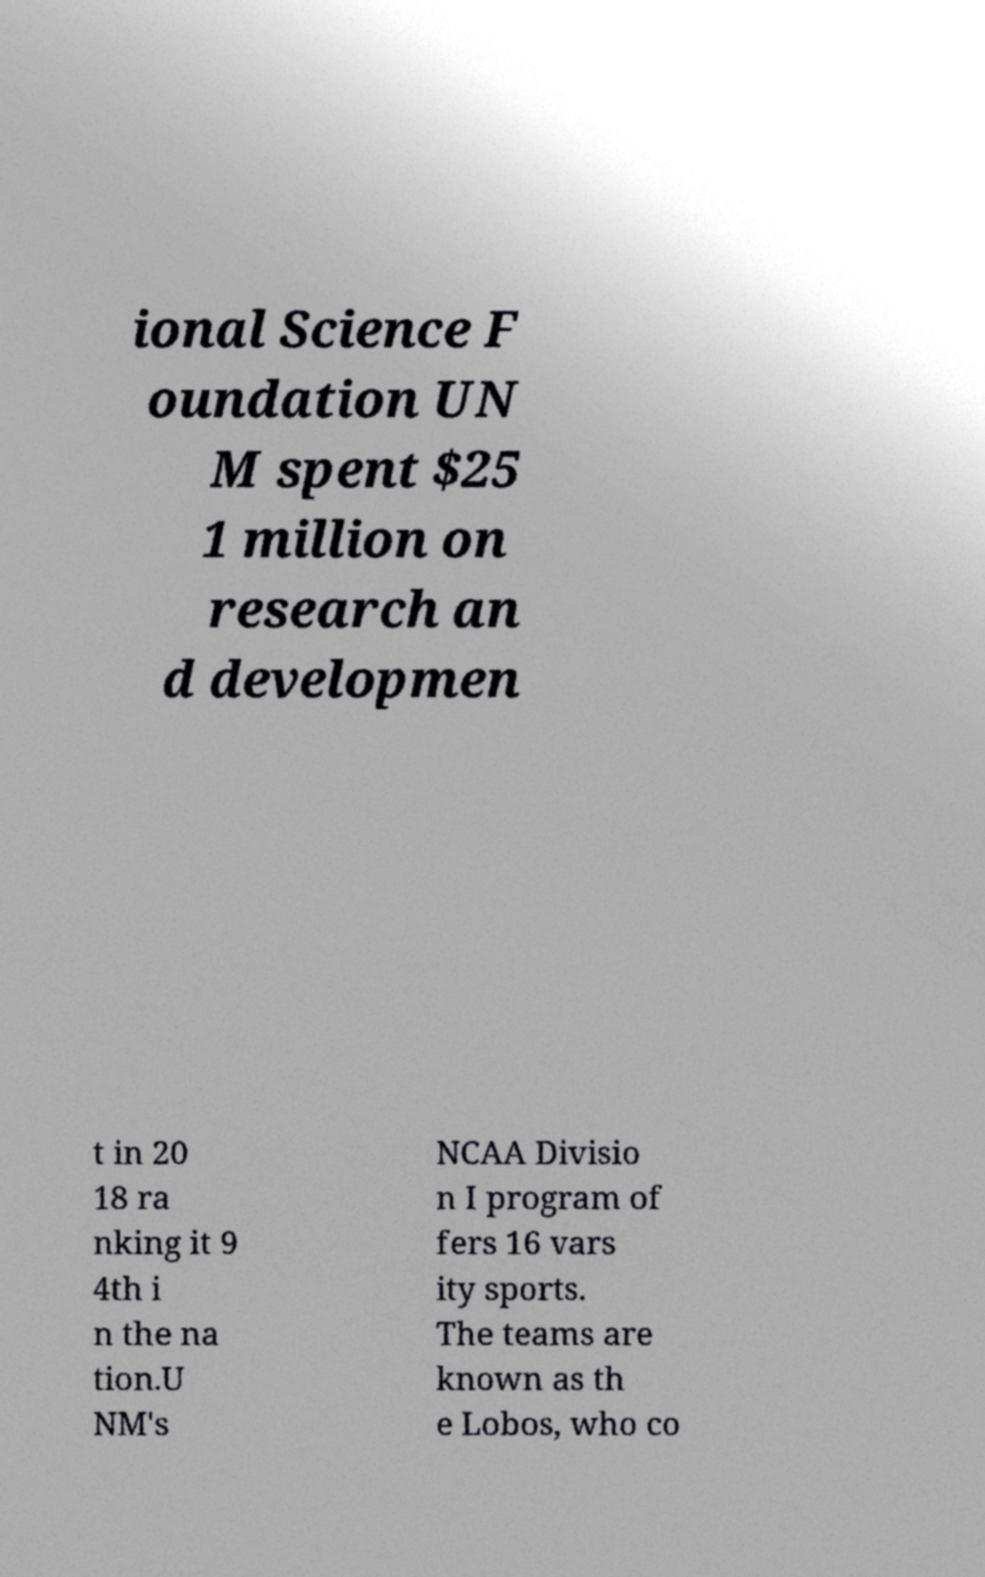Can you read and provide the text displayed in the image?This photo seems to have some interesting text. Can you extract and type it out for me? ional Science F oundation UN M spent $25 1 million on research an d developmen t in 20 18 ra nking it 9 4th i n the na tion.U NM's NCAA Divisio n I program of fers 16 vars ity sports. The teams are known as th e Lobos, who co 